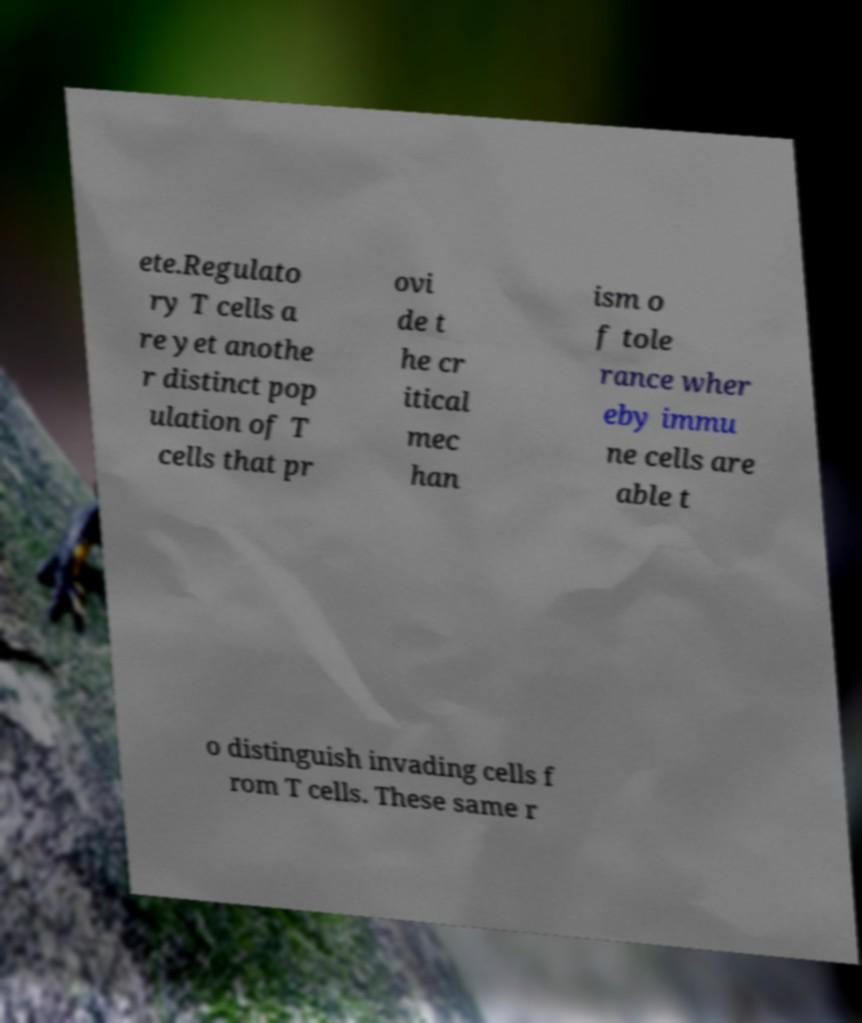For documentation purposes, I need the text within this image transcribed. Could you provide that? ete.Regulato ry T cells a re yet anothe r distinct pop ulation of T cells that pr ovi de t he cr itical mec han ism o f tole rance wher eby immu ne cells are able t o distinguish invading cells f rom T cells. These same r 